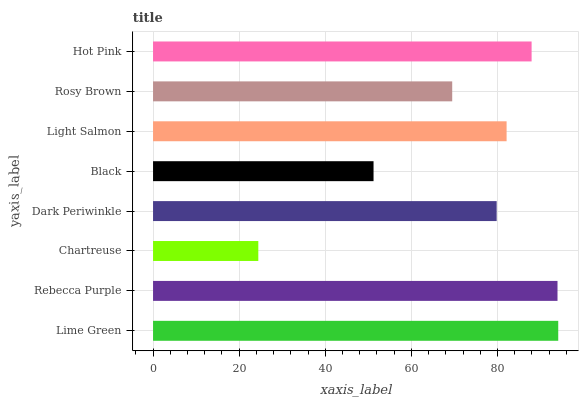Is Chartreuse the minimum?
Answer yes or no. Yes. Is Lime Green the maximum?
Answer yes or no. Yes. Is Rebecca Purple the minimum?
Answer yes or no. No. Is Rebecca Purple the maximum?
Answer yes or no. No. Is Lime Green greater than Rebecca Purple?
Answer yes or no. Yes. Is Rebecca Purple less than Lime Green?
Answer yes or no. Yes. Is Rebecca Purple greater than Lime Green?
Answer yes or no. No. Is Lime Green less than Rebecca Purple?
Answer yes or no. No. Is Light Salmon the high median?
Answer yes or no. Yes. Is Dark Periwinkle the low median?
Answer yes or no. Yes. Is Lime Green the high median?
Answer yes or no. No. Is Hot Pink the low median?
Answer yes or no. No. 